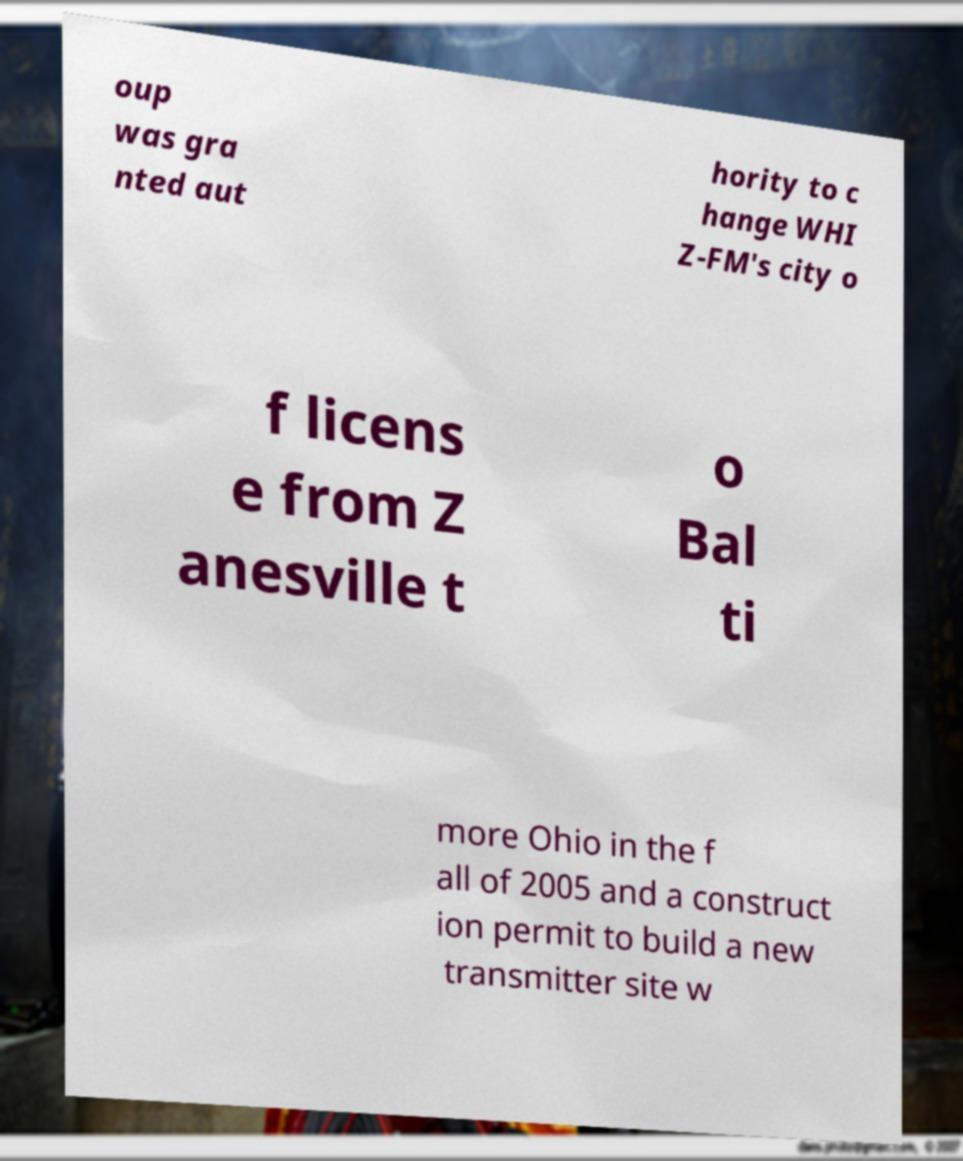There's text embedded in this image that I need extracted. Can you transcribe it verbatim? oup was gra nted aut hority to c hange WHI Z-FM's city o f licens e from Z anesville t o Bal ti more Ohio in the f all of 2005 and a construct ion permit to build a new transmitter site w 